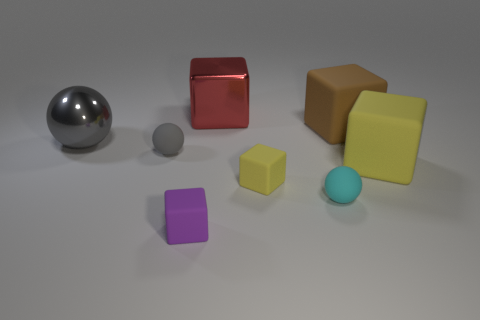What is the size of the rubber object that is the same color as the large ball?
Make the answer very short. Small. What is the material of the tiny block behind the purple rubber cube?
Ensure brevity in your answer.  Rubber. What size is the other object that is made of the same material as the red thing?
Give a very brief answer. Large. How many large red things have the same shape as the large yellow rubber object?
Give a very brief answer. 1. There is a big yellow matte object; is its shape the same as the object to the left of the tiny gray rubber object?
Your response must be concise. No. Are there any tiny gray blocks that have the same material as the big gray sphere?
Provide a succinct answer. No. Is there anything else that is made of the same material as the big gray object?
Your answer should be compact. Yes. What material is the small gray object that is left of the small object in front of the cyan sphere?
Offer a terse response. Rubber. There is a yellow matte thing that is in front of the yellow thing on the right side of the tiny object right of the small yellow rubber block; how big is it?
Offer a very short reply. Small. What number of other things are there of the same shape as the large brown matte thing?
Your answer should be compact. 4. 